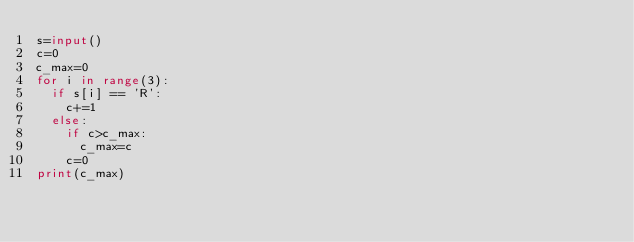<code> <loc_0><loc_0><loc_500><loc_500><_Python_>s=input()
c=0
c_max=0
for i in range(3):
  if s[i] == 'R':
    c+=1
  else:
    if c>c_max:
      c_max=c
    c=0
print(c_max)</code> 